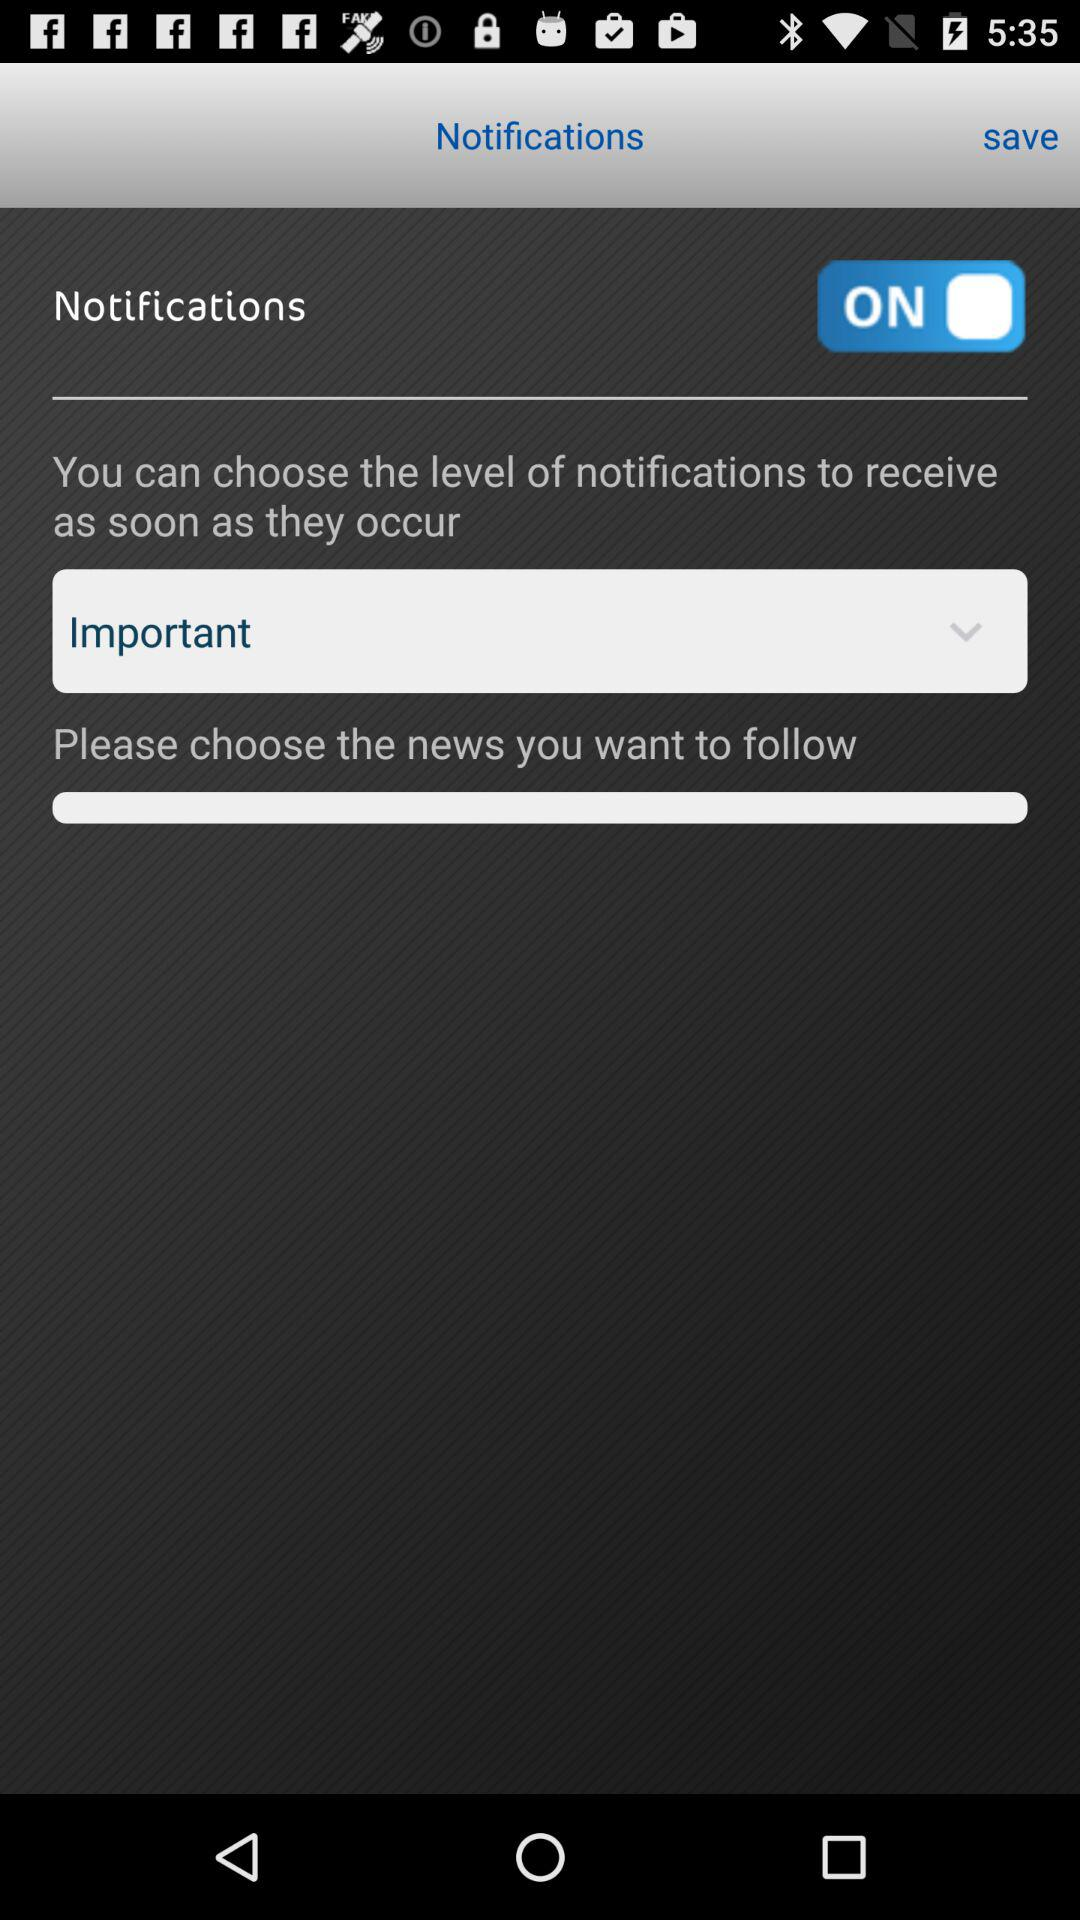What's the status of "Notifications"? The status is "on". 